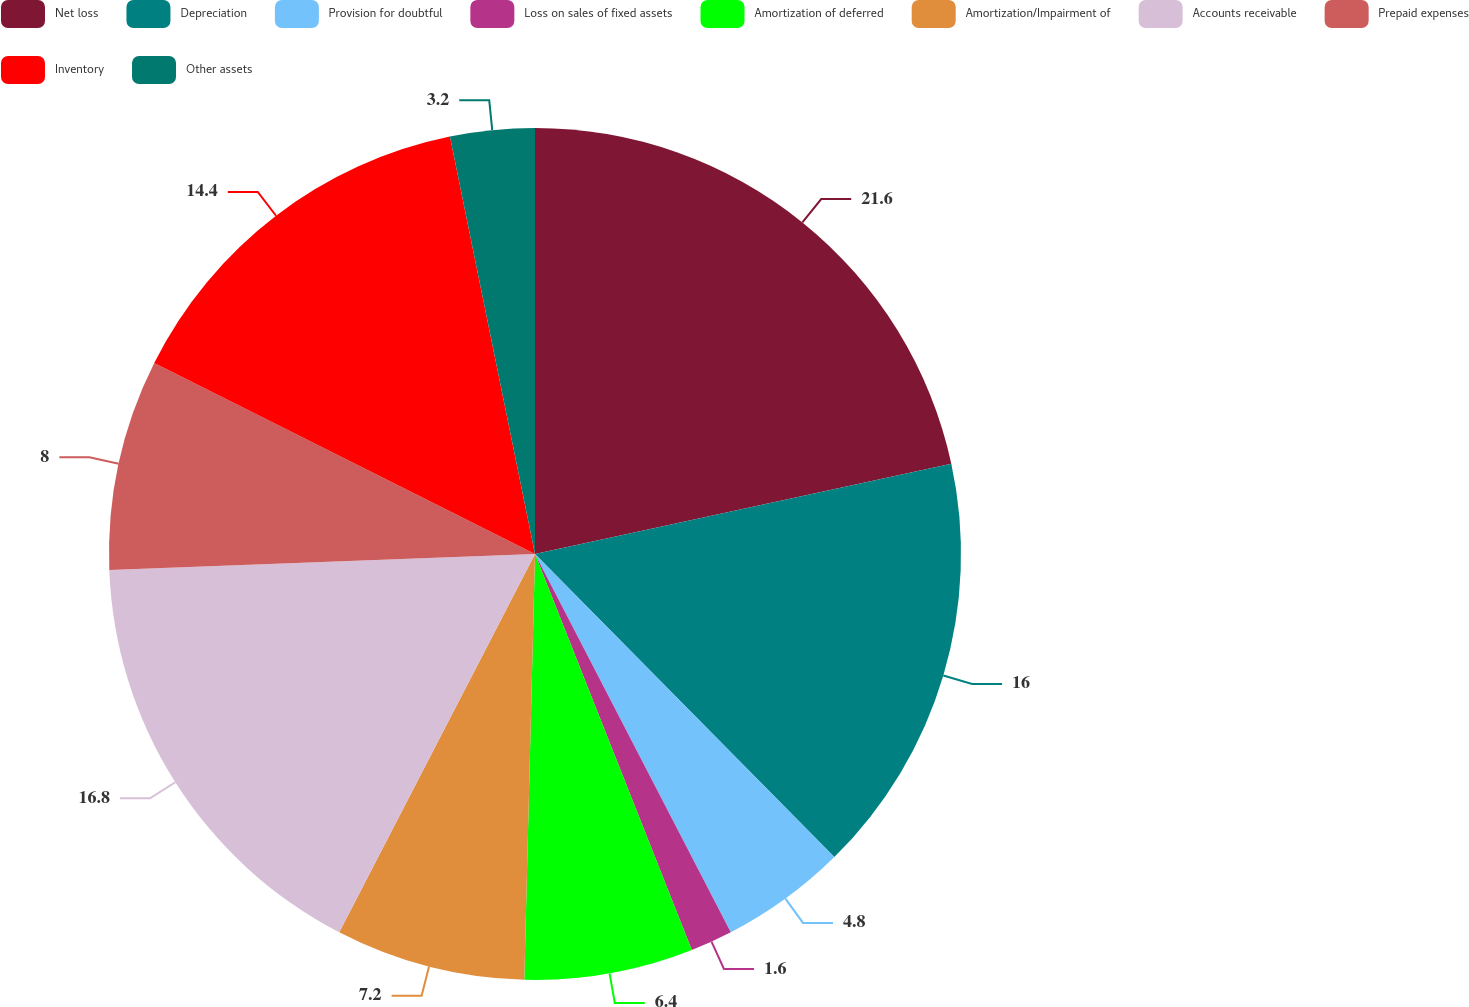Convert chart to OTSL. <chart><loc_0><loc_0><loc_500><loc_500><pie_chart><fcel>Net loss<fcel>Depreciation<fcel>Provision for doubtful<fcel>Loss on sales of fixed assets<fcel>Amortization of deferred<fcel>Amortization/Impairment of<fcel>Accounts receivable<fcel>Prepaid expenses<fcel>Inventory<fcel>Other assets<nl><fcel>21.6%<fcel>16.0%<fcel>4.8%<fcel>1.6%<fcel>6.4%<fcel>7.2%<fcel>16.8%<fcel>8.0%<fcel>14.4%<fcel>3.2%<nl></chart> 